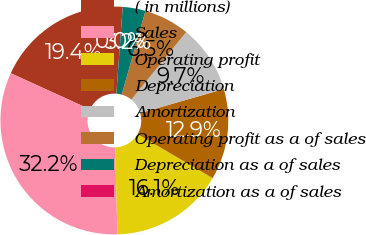Convert chart. <chart><loc_0><loc_0><loc_500><loc_500><pie_chart><fcel>( in millions)<fcel>Sales<fcel>Operating profit<fcel>Depreciation<fcel>Amortization<fcel>Operating profit as a of sales<fcel>Depreciation as a of sales<fcel>Amortization as a of sales<nl><fcel>19.35%<fcel>32.24%<fcel>16.13%<fcel>12.9%<fcel>9.68%<fcel>6.46%<fcel>3.23%<fcel>0.01%<nl></chart> 